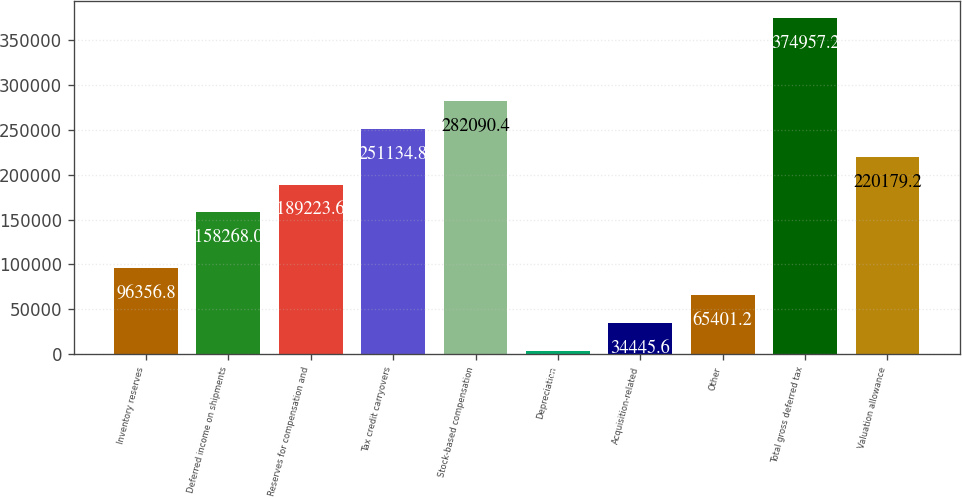Convert chart to OTSL. <chart><loc_0><loc_0><loc_500><loc_500><bar_chart><fcel>Inventory reserves<fcel>Deferred income on shipments<fcel>Reserves for compensation and<fcel>Tax credit carryovers<fcel>Stock-based compensation<fcel>Depreciation<fcel>Acquisition-related<fcel>Other<fcel>Total gross deferred tax<fcel>Valuation allowance<nl><fcel>96356.8<fcel>158268<fcel>189224<fcel>251135<fcel>282090<fcel>3490<fcel>34445.6<fcel>65401.2<fcel>374957<fcel>220179<nl></chart> 